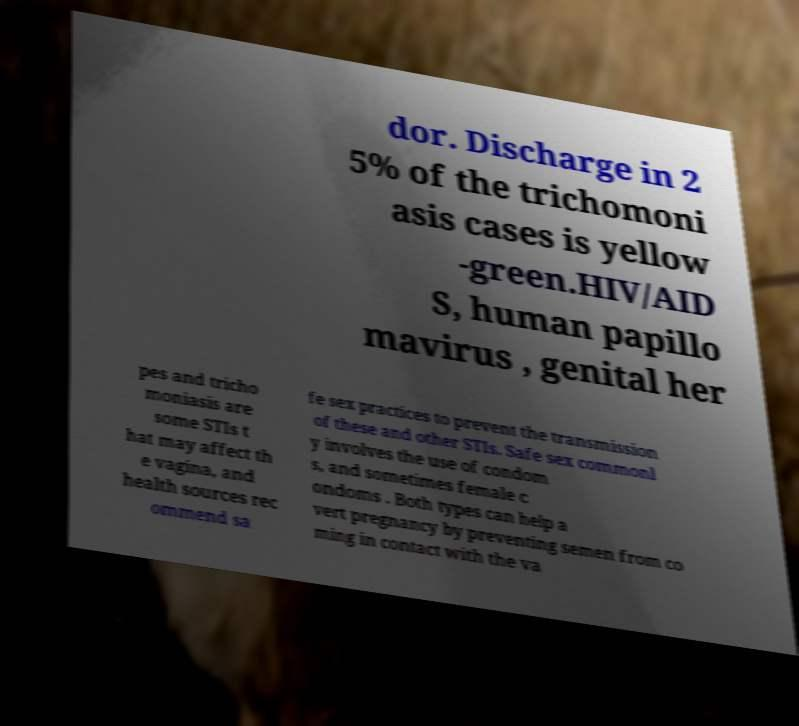Could you extract and type out the text from this image? dor. Discharge in 2 5% of the trichomoni asis cases is yellow -green.HIV/AID S, human papillo mavirus , genital her pes and tricho moniasis are some STIs t hat may affect th e vagina, and health sources rec ommend sa fe sex practices to prevent the transmission of these and other STIs. Safe sex commonl y involves the use of condom s, and sometimes female c ondoms . Both types can help a vert pregnancy by preventing semen from co ming in contact with the va 